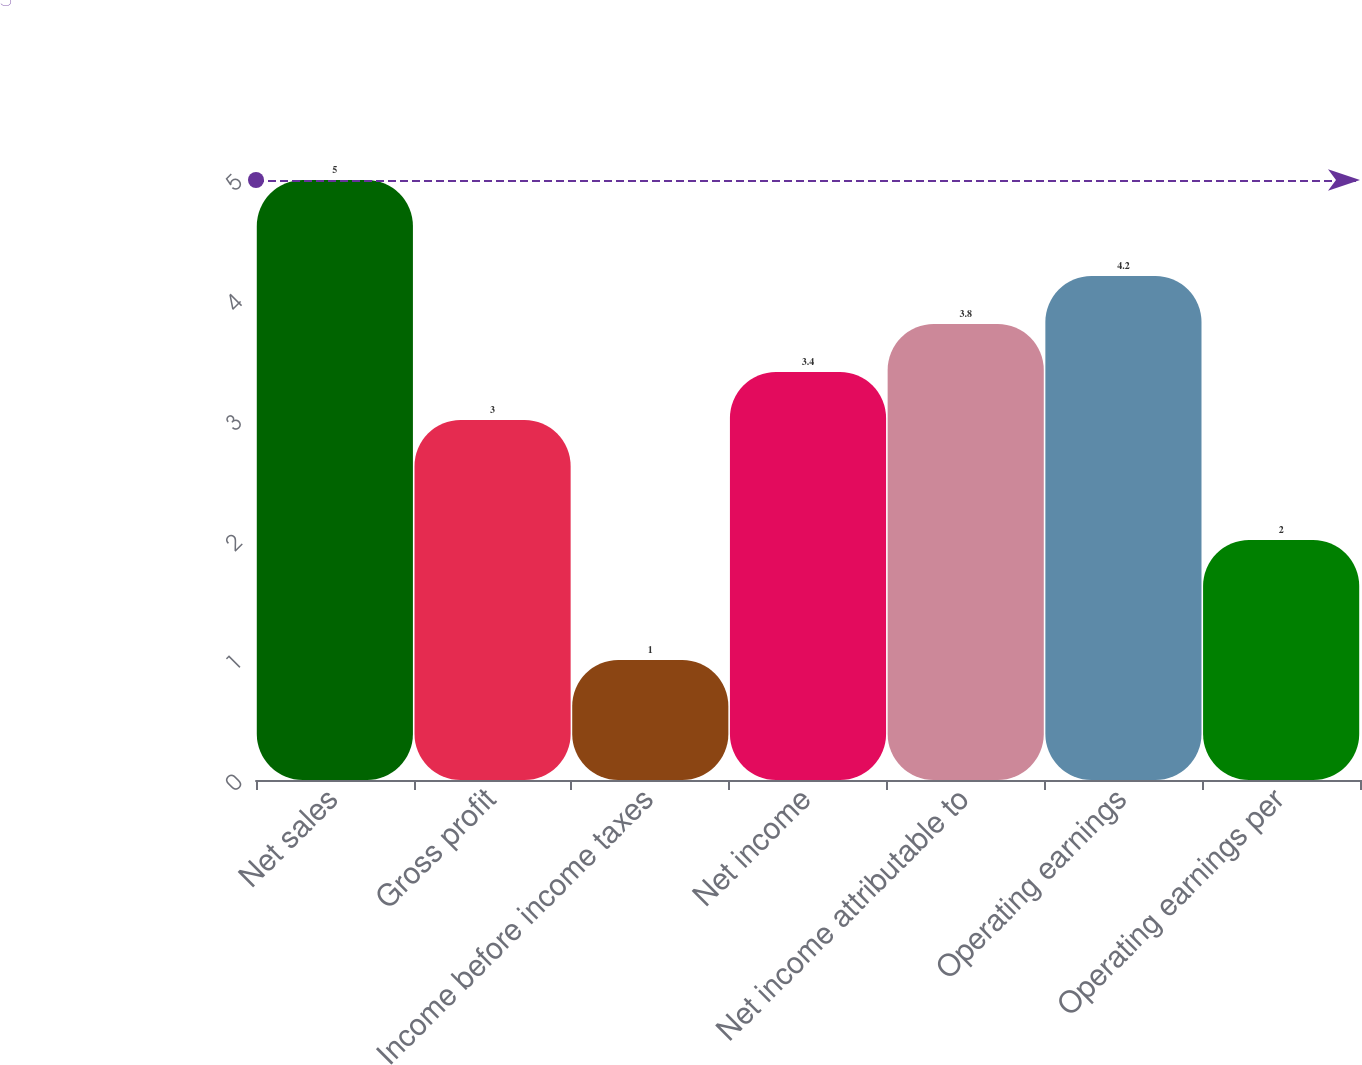Convert chart. <chart><loc_0><loc_0><loc_500><loc_500><bar_chart><fcel>Net sales<fcel>Gross profit<fcel>Income before income taxes<fcel>Net income<fcel>Net income attributable to<fcel>Operating earnings<fcel>Operating earnings per<nl><fcel>5<fcel>3<fcel>1<fcel>3.4<fcel>3.8<fcel>4.2<fcel>2<nl></chart> 